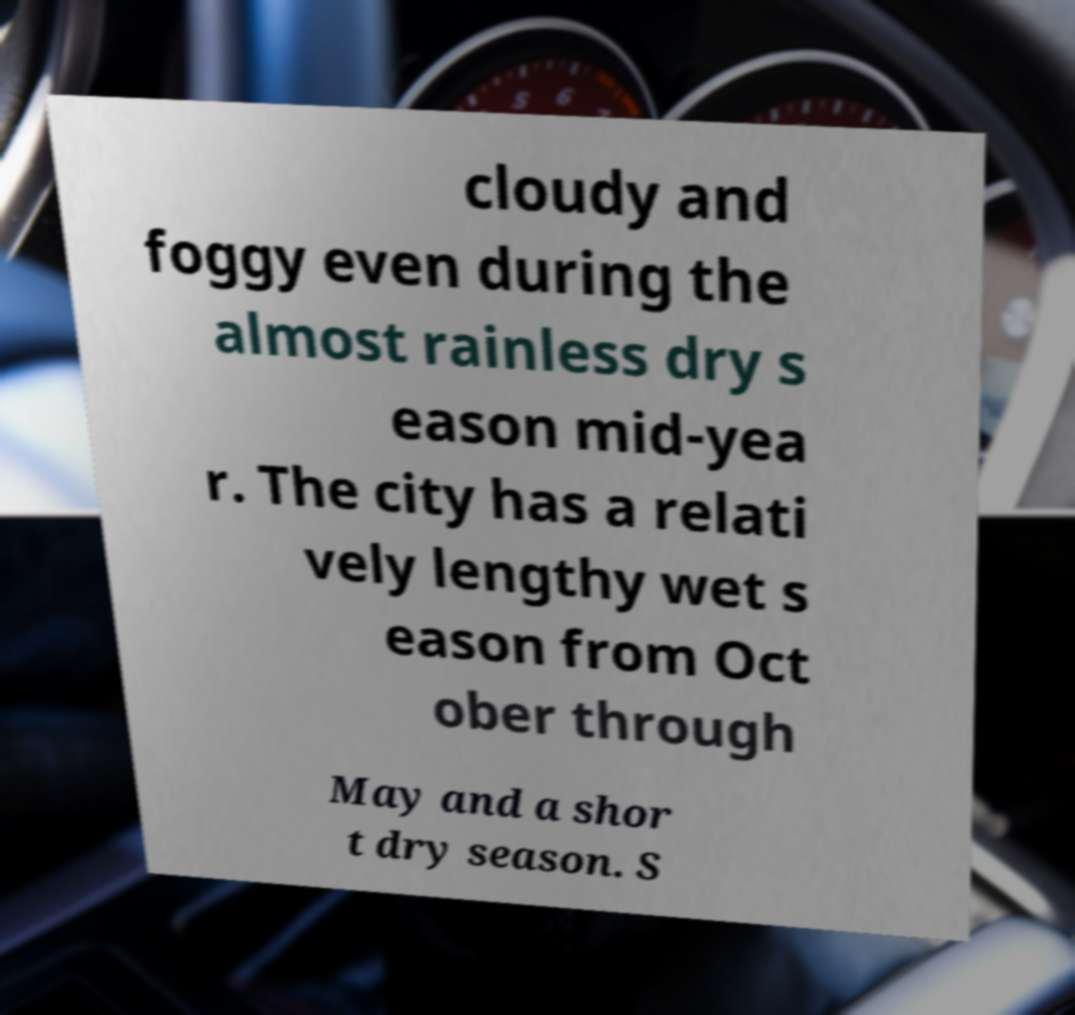Could you assist in decoding the text presented in this image and type it out clearly? cloudy and foggy even during the almost rainless dry s eason mid-yea r. The city has a relati vely lengthy wet s eason from Oct ober through May and a shor t dry season. S 